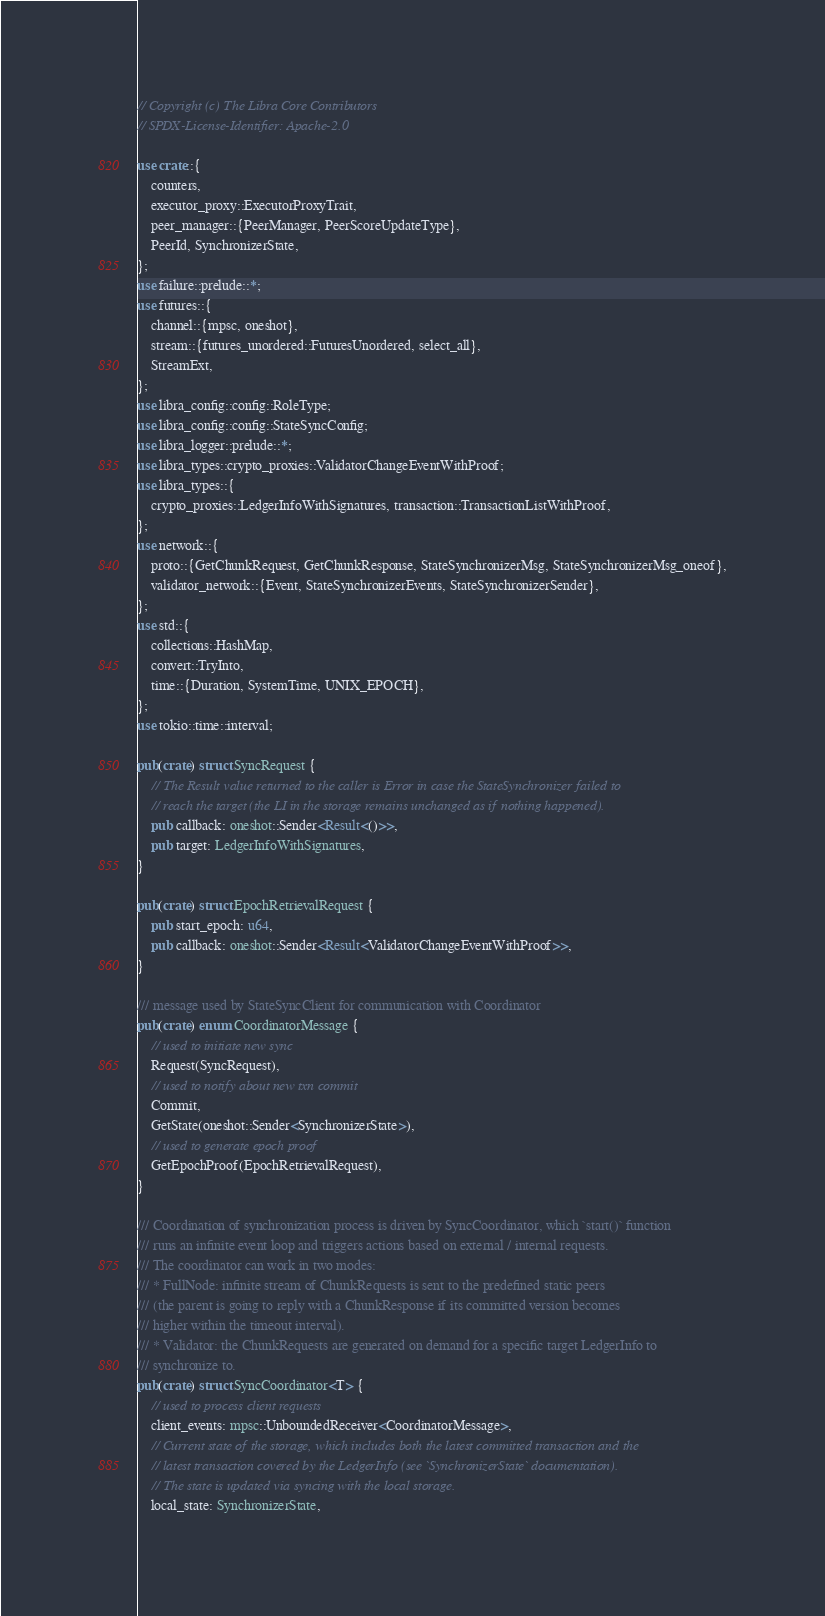<code> <loc_0><loc_0><loc_500><loc_500><_Rust_>// Copyright (c) The Libra Core Contributors
// SPDX-License-Identifier: Apache-2.0

use crate::{
    counters,
    executor_proxy::ExecutorProxyTrait,
    peer_manager::{PeerManager, PeerScoreUpdateType},
    PeerId, SynchronizerState,
};
use failure::prelude::*;
use futures::{
    channel::{mpsc, oneshot},
    stream::{futures_unordered::FuturesUnordered, select_all},
    StreamExt,
};
use libra_config::config::RoleType;
use libra_config::config::StateSyncConfig;
use libra_logger::prelude::*;
use libra_types::crypto_proxies::ValidatorChangeEventWithProof;
use libra_types::{
    crypto_proxies::LedgerInfoWithSignatures, transaction::TransactionListWithProof,
};
use network::{
    proto::{GetChunkRequest, GetChunkResponse, StateSynchronizerMsg, StateSynchronizerMsg_oneof},
    validator_network::{Event, StateSynchronizerEvents, StateSynchronizerSender},
};
use std::{
    collections::HashMap,
    convert::TryInto,
    time::{Duration, SystemTime, UNIX_EPOCH},
};
use tokio::time::interval;

pub(crate) struct SyncRequest {
    // The Result value returned to the caller is Error in case the StateSynchronizer failed to
    // reach the target (the LI in the storage remains unchanged as if nothing happened).
    pub callback: oneshot::Sender<Result<()>>,
    pub target: LedgerInfoWithSignatures,
}

pub(crate) struct EpochRetrievalRequest {
    pub start_epoch: u64,
    pub callback: oneshot::Sender<Result<ValidatorChangeEventWithProof>>,
}

/// message used by StateSyncClient for communication with Coordinator
pub(crate) enum CoordinatorMessage {
    // used to initiate new sync
    Request(SyncRequest),
    // used to notify about new txn commit
    Commit,
    GetState(oneshot::Sender<SynchronizerState>),
    // used to generate epoch proof
    GetEpochProof(EpochRetrievalRequest),
}

/// Coordination of synchronization process is driven by SyncCoordinator, which `start()` function
/// runs an infinite event loop and triggers actions based on external / internal requests.
/// The coordinator can work in two modes:
/// * FullNode: infinite stream of ChunkRequests is sent to the predefined static peers
/// (the parent is going to reply with a ChunkResponse if its committed version becomes
/// higher within the timeout interval).
/// * Validator: the ChunkRequests are generated on demand for a specific target LedgerInfo to
/// synchronize to.
pub(crate) struct SyncCoordinator<T> {
    // used to process client requests
    client_events: mpsc::UnboundedReceiver<CoordinatorMessage>,
    // Current state of the storage, which includes both the latest committed transaction and the
    // latest transaction covered by the LedgerInfo (see `SynchronizerState` documentation).
    // The state is updated via syncing with the local storage.
    local_state: SynchronizerState,</code> 